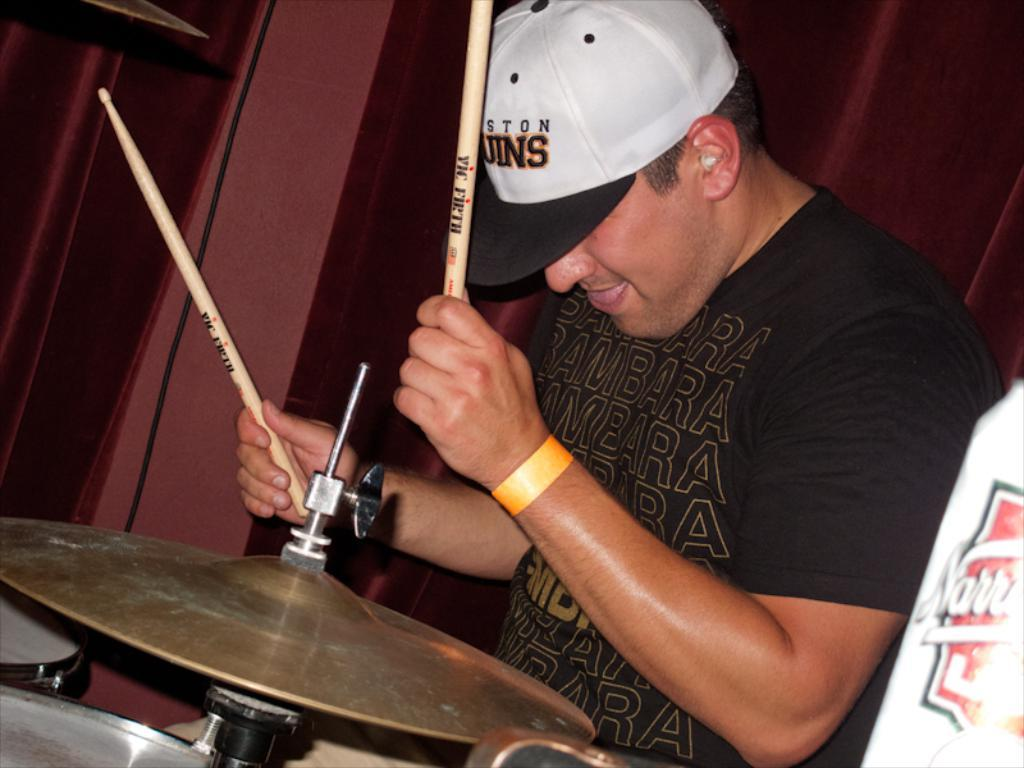Provide a one-sentence caption for the provided image. A man in a Boston Bruins caps playing drums. 